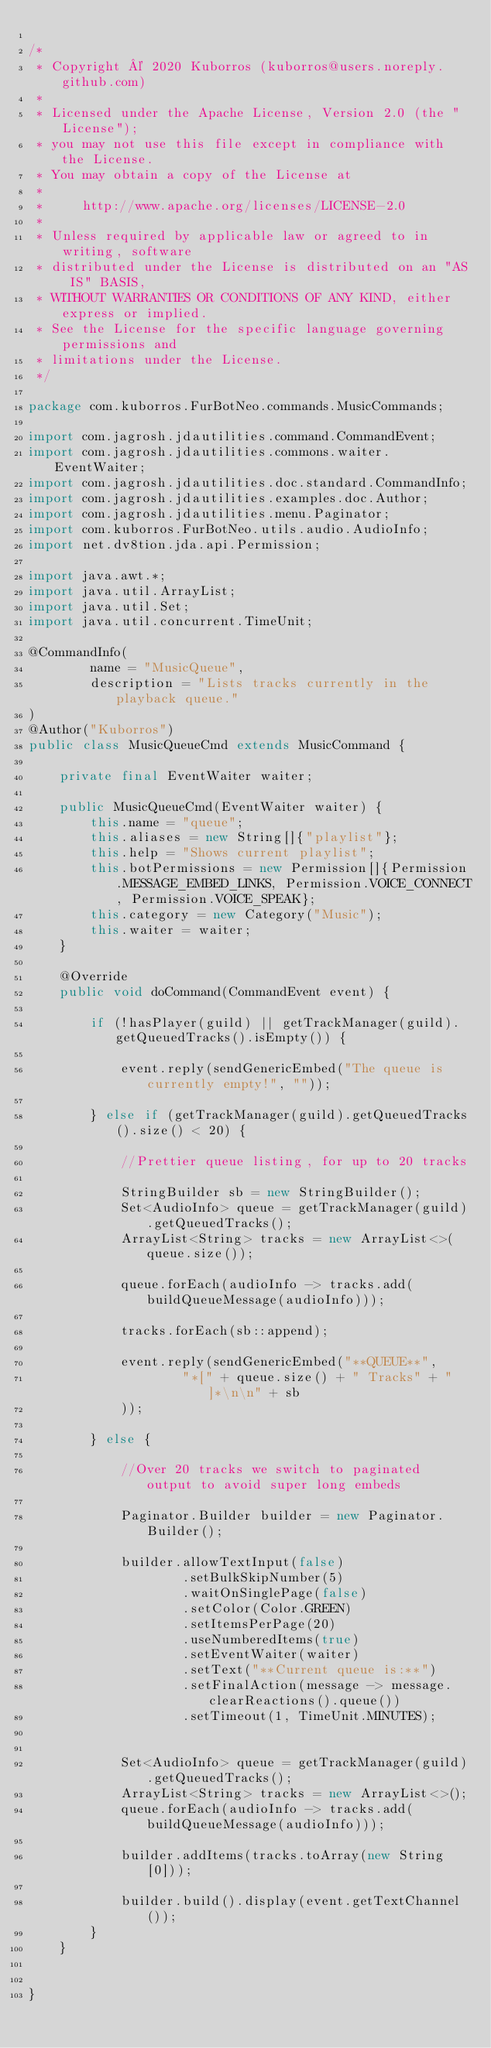Convert code to text. <code><loc_0><loc_0><loc_500><loc_500><_Java_>
/*
 * Copyright © 2020 Kuborros (kuborros@users.noreply.github.com)
 *
 * Licensed under the Apache License, Version 2.0 (the "License");
 * you may not use this file except in compliance with the License.
 * You may obtain a copy of the License at
 *
 *     http://www.apache.org/licenses/LICENSE-2.0
 *
 * Unless required by applicable law or agreed to in writing, software
 * distributed under the License is distributed on an "AS IS" BASIS,
 * WITHOUT WARRANTIES OR CONDITIONS OF ANY KIND, either express or implied.
 * See the License for the specific language governing permissions and
 * limitations under the License.
 */

package com.kuborros.FurBotNeo.commands.MusicCommands;

import com.jagrosh.jdautilities.command.CommandEvent;
import com.jagrosh.jdautilities.commons.waiter.EventWaiter;
import com.jagrosh.jdautilities.doc.standard.CommandInfo;
import com.jagrosh.jdautilities.examples.doc.Author;
import com.jagrosh.jdautilities.menu.Paginator;
import com.kuborros.FurBotNeo.utils.audio.AudioInfo;
import net.dv8tion.jda.api.Permission;

import java.awt.*;
import java.util.ArrayList;
import java.util.Set;
import java.util.concurrent.TimeUnit;

@CommandInfo(
        name = "MusicQueue",
        description = "Lists tracks currently in the playback queue."
)
@Author("Kuborros")
public class MusicQueueCmd extends MusicCommand {

    private final EventWaiter waiter;

    public MusicQueueCmd(EventWaiter waiter) {
        this.name = "queue";
        this.aliases = new String[]{"playlist"};
        this.help = "Shows current playlist";
        this.botPermissions = new Permission[]{Permission.MESSAGE_EMBED_LINKS, Permission.VOICE_CONNECT, Permission.VOICE_SPEAK};
        this.category = new Category("Music");
        this.waiter = waiter;
    }

    @Override
    public void doCommand(CommandEvent event) {

        if (!hasPlayer(guild) || getTrackManager(guild).getQueuedTracks().isEmpty()) {

            event.reply(sendGenericEmbed("The queue is currently empty!", ""));

        } else if (getTrackManager(guild).getQueuedTracks().size() < 20) {

            //Prettier queue listing, for up to 20 tracks

            StringBuilder sb = new StringBuilder();
            Set<AudioInfo> queue = getTrackManager(guild).getQueuedTracks();
            ArrayList<String> tracks = new ArrayList<>(queue.size());

            queue.forEach(audioInfo -> tracks.add(buildQueueMessage(audioInfo)));

            tracks.forEach(sb::append);

            event.reply(sendGenericEmbed("**QUEUE**",
                    "*[" + queue.size() + " Tracks" + "]*\n\n" + sb
            ));

        } else {

            //Over 20 tracks we switch to paginated output to avoid super long embeds

            Paginator.Builder builder = new Paginator.Builder();

            builder.allowTextInput(false)
                    .setBulkSkipNumber(5)
                    .waitOnSinglePage(false)
                    .setColor(Color.GREEN)
                    .setItemsPerPage(20)
                    .useNumberedItems(true)
                    .setEventWaiter(waiter)
                    .setText("**Current queue is:**")
                    .setFinalAction(message -> message.clearReactions().queue())
                    .setTimeout(1, TimeUnit.MINUTES);


            Set<AudioInfo> queue = getTrackManager(guild).getQueuedTracks();
            ArrayList<String> tracks = new ArrayList<>();
            queue.forEach(audioInfo -> tracks.add(buildQueueMessage(audioInfo)));

            builder.addItems(tracks.toArray(new String[0]));

            builder.build().display(event.getTextChannel());
        }
    }


}</code> 